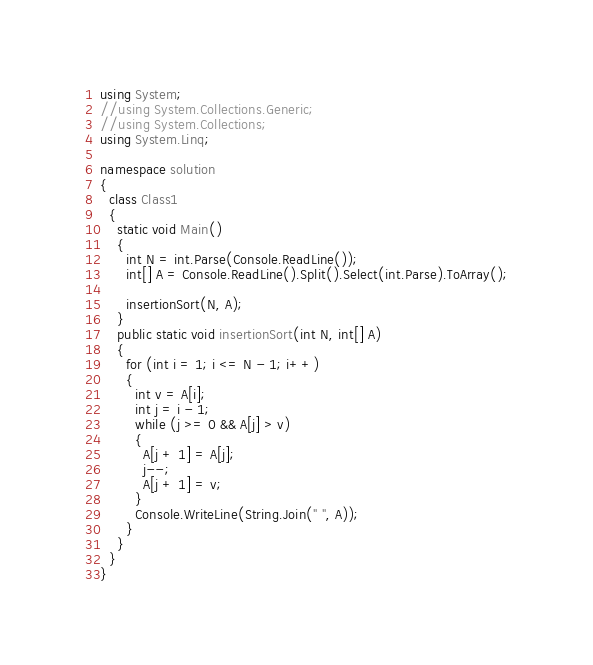<code> <loc_0><loc_0><loc_500><loc_500><_C#_>using System;
//using System.Collections.Generic;
//using System.Collections;
using System.Linq;

namespace solution
{
  class Class1
  {
    static void Main()
    {
      int N = int.Parse(Console.ReadLine());
      int[] A = Console.ReadLine().Split().Select(int.Parse).ToArray();

      insertionSort(N, A);
    }
    public static void insertionSort(int N, int[] A)
    {
      for (int i = 1; i <= N - 1; i++)
      {
        int v = A[i];
        int j = i - 1;
        while (j >= 0 && A[j] > v)
        {
          A[j + 1] = A[j];
          j--;
          A[j + 1] = v;
        }
        Console.WriteLine(String.Join(" ", A));
      }
    }
  }
}






</code> 